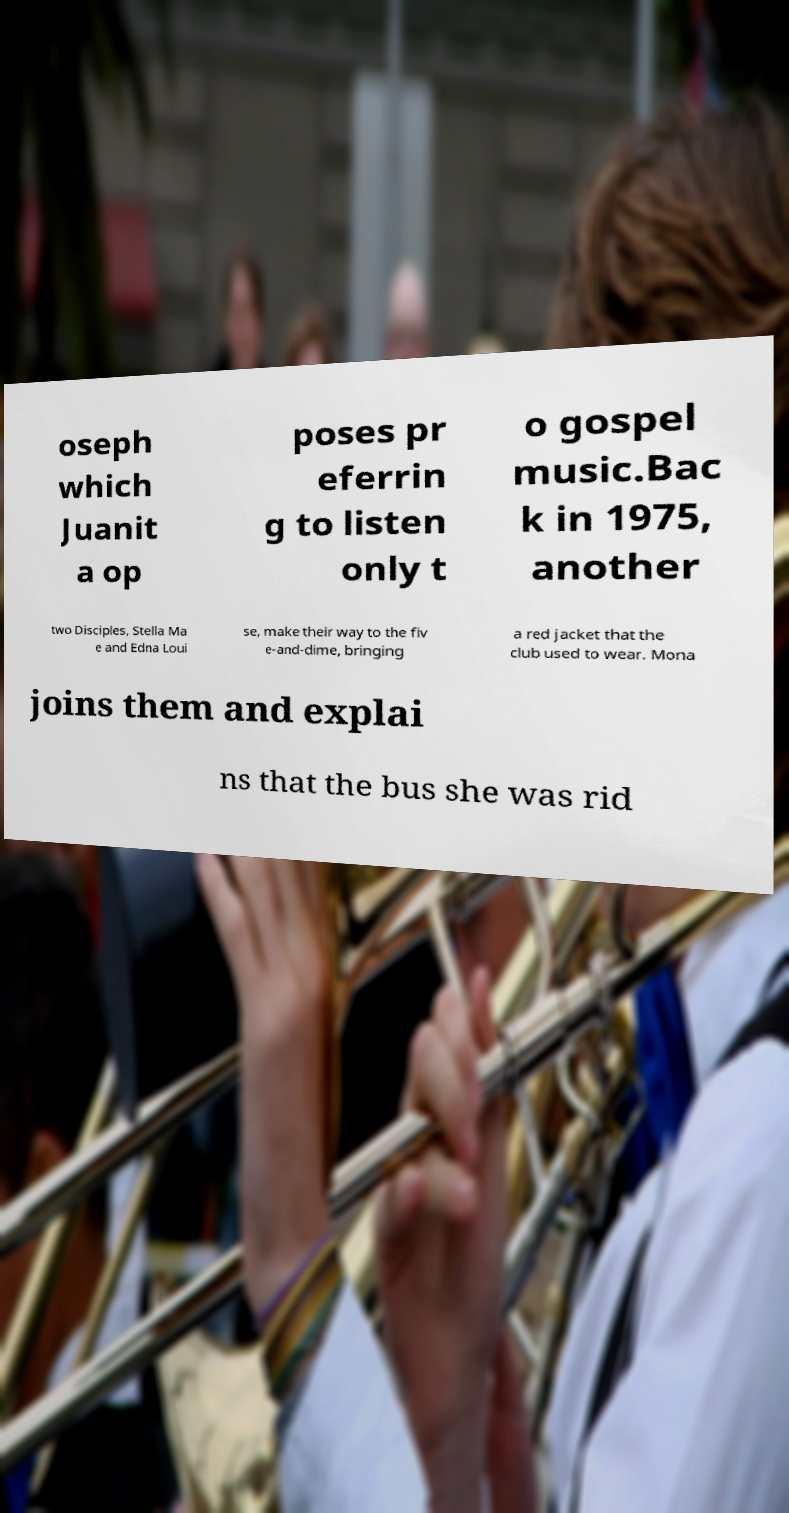Please read and relay the text visible in this image. What does it say? oseph which Juanit a op poses pr eferrin g to listen only t o gospel music.Bac k in 1975, another two Disciples, Stella Ma e and Edna Loui se, make their way to the fiv e-and-dime, bringing a red jacket that the club used to wear. Mona joins them and explai ns that the bus she was rid 